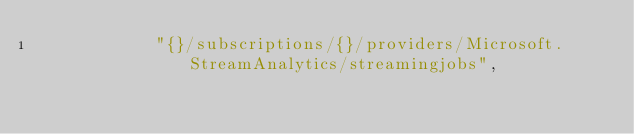<code> <loc_0><loc_0><loc_500><loc_500><_Rust_>            "{}/subscriptions/{}/providers/Microsoft.StreamAnalytics/streamingjobs",</code> 